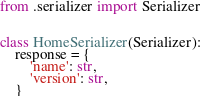<code> <loc_0><loc_0><loc_500><loc_500><_Python_>from .serializer import Serializer


class HomeSerializer(Serializer):
    response = {
        'name': str,
        'version': str,
    }
</code> 